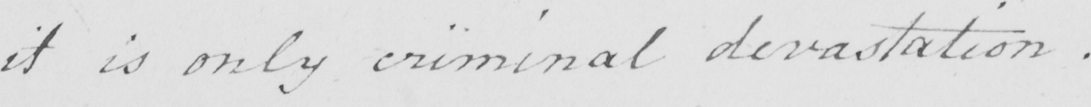Can you tell me what this handwritten text says? it is only criminal devastation . 